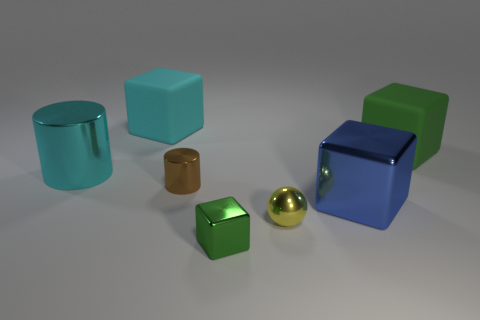Are there any other things that have the same shape as the yellow shiny thing?
Your answer should be compact. No. Is the number of large metal blocks behind the large cyan matte object the same as the number of purple matte cubes?
Your response must be concise. Yes. What is the material of the green object that is left of the green thing behind the cyan object that is to the left of the cyan block?
Offer a very short reply. Metal. What number of objects are big cubes that are left of the tiny brown metallic thing or big yellow matte cylinders?
Make the answer very short. 1. How many things are either blue objects or matte cubes in front of the big cyan rubber object?
Your answer should be compact. 2. What number of shiny balls are right of the big rubber object that is to the left of the large block in front of the brown shiny cylinder?
Make the answer very short. 1. What material is the brown object that is the same size as the yellow thing?
Ensure brevity in your answer.  Metal. Is there a yellow matte object that has the same size as the cyan cylinder?
Offer a very short reply. No. What is the color of the ball?
Your response must be concise. Yellow. What color is the block behind the large block to the right of the large blue thing?
Provide a short and direct response. Cyan. 